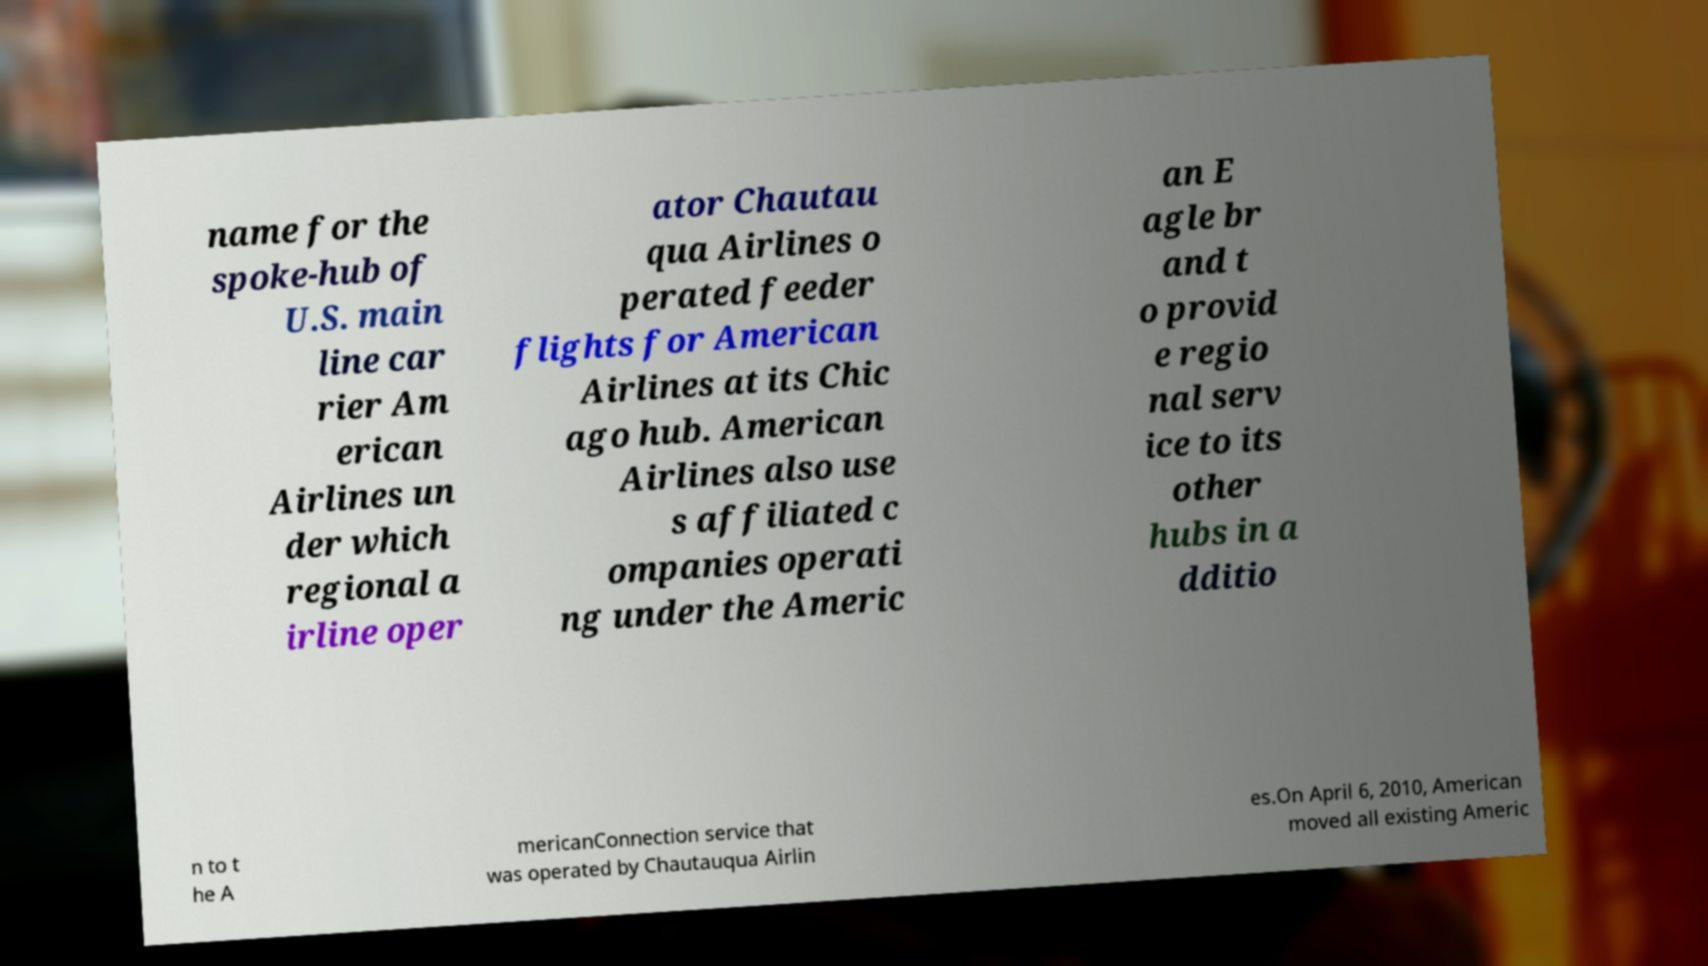Can you accurately transcribe the text from the provided image for me? name for the spoke-hub of U.S. main line car rier Am erican Airlines un der which regional a irline oper ator Chautau qua Airlines o perated feeder flights for American Airlines at its Chic ago hub. American Airlines also use s affiliated c ompanies operati ng under the Americ an E agle br and t o provid e regio nal serv ice to its other hubs in a dditio n to t he A mericanConnection service that was operated by Chautauqua Airlin es.On April 6, 2010, American moved all existing Americ 